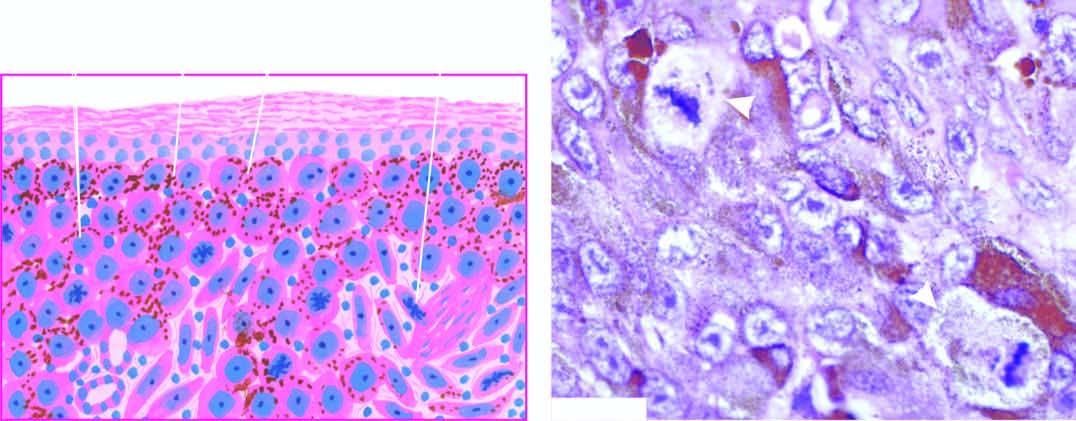what contain fine granular melanin pigment?
Answer the question using a single word or phrase. Many of the tumour cells 